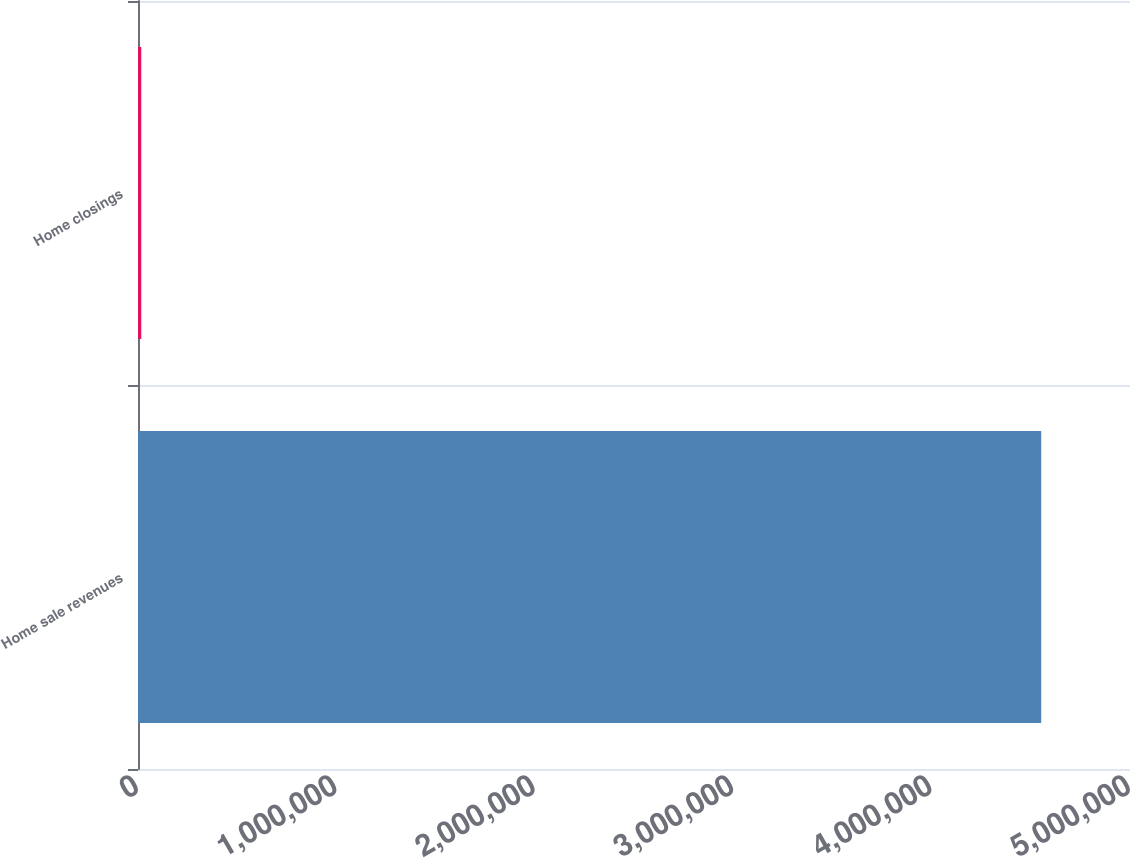Convert chart to OTSL. <chart><loc_0><loc_0><loc_500><loc_500><bar_chart><fcel>Home sale revenues<fcel>Home closings<nl><fcel>4.55241e+06<fcel>16505<nl></chart> 